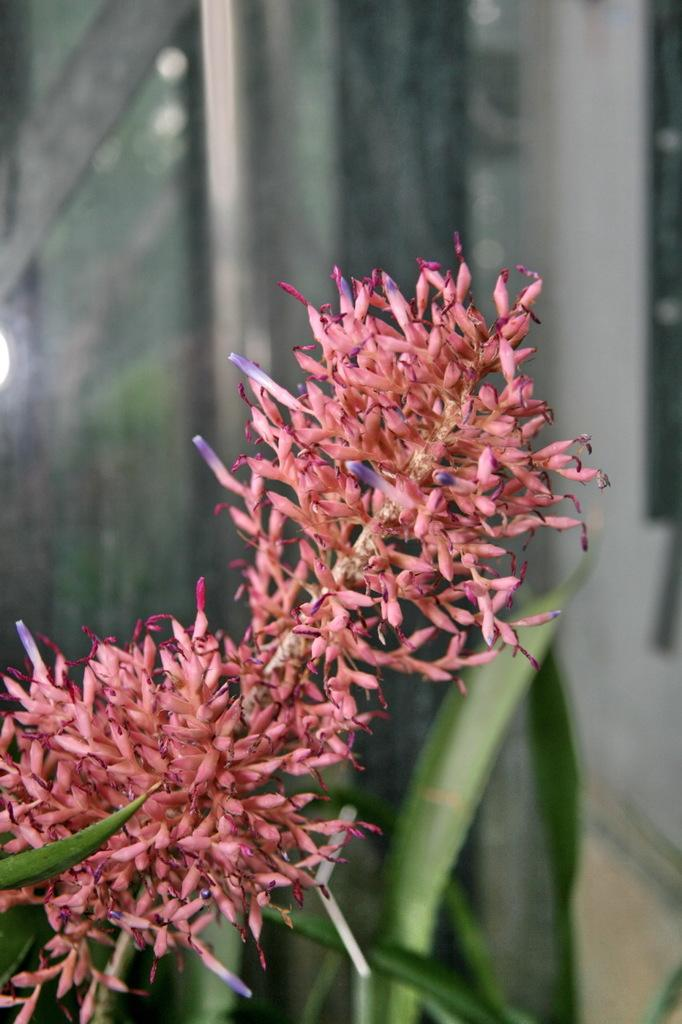What types of flowers are present in the image? There are red and purple color flowers in the image. Can you describe the background of the image? The background of the image is blurred. What type of juice is being squeezed from the flowers in the image? There is no juice being squeezed from the flowers in the image; it is a still image of flowers. What type of dust can be seen on the petals of the flowers in the image? There is no dust present on the petals of the flowers in the image. 